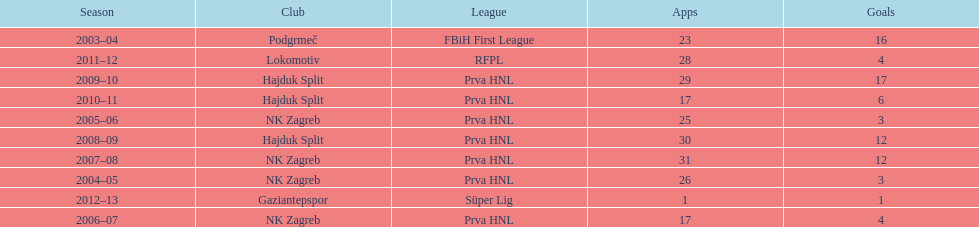The team with the most goals Hajduk Split. 